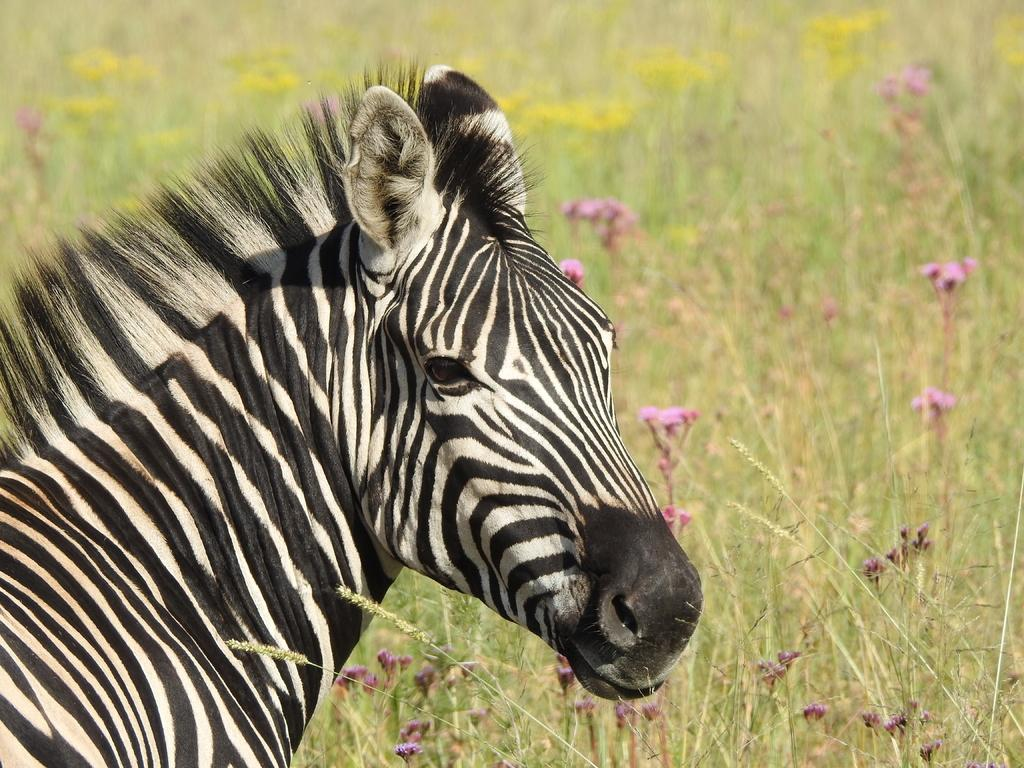What animal is on the left side of the image? There is a zebra on the left side of the image. What can be seen in the background of the image? There are plants and flowers in the background of the image. What type of potato is being harvested in the image? There is no potato present in the image; it features a zebra and plants in the background. What season is depicted in the image? The provided facts do not indicate a specific season, so it cannot be determined from the image. 